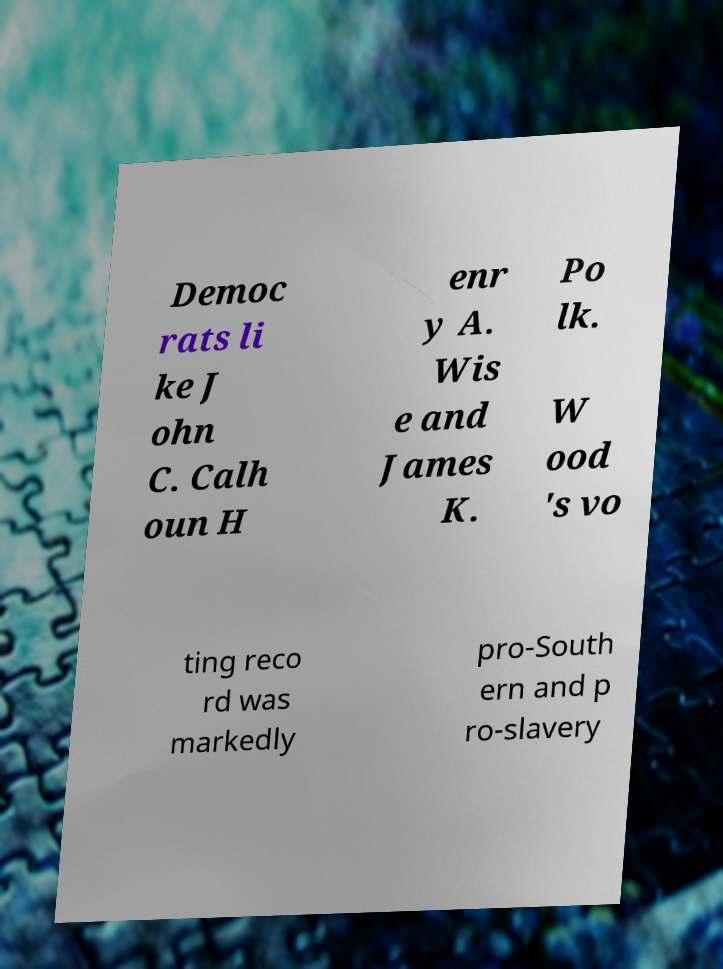Please identify and transcribe the text found in this image. Democ rats li ke J ohn C. Calh oun H enr y A. Wis e and James K. Po lk. W ood 's vo ting reco rd was markedly pro-South ern and p ro-slavery 